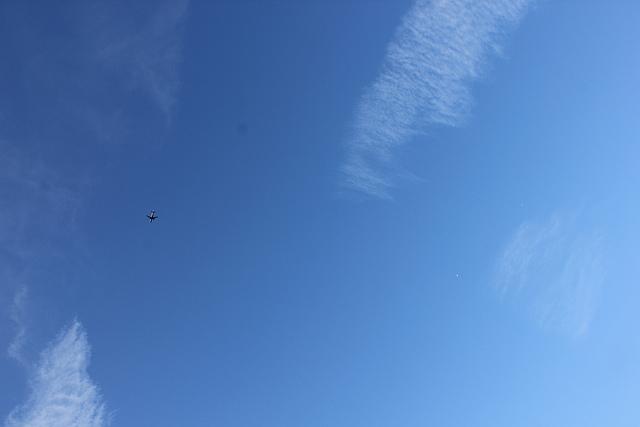Where is the plane going?
Quick response, please. South. Are there storm clouds?
Keep it brief. No. Is there anything in the sky?
Write a very short answer. Yes. Is it a clear sky?
Answer briefly. Yes. Is the plane far away?
Short answer required. Yes. The spray from the waves?
Keep it brief. No. 